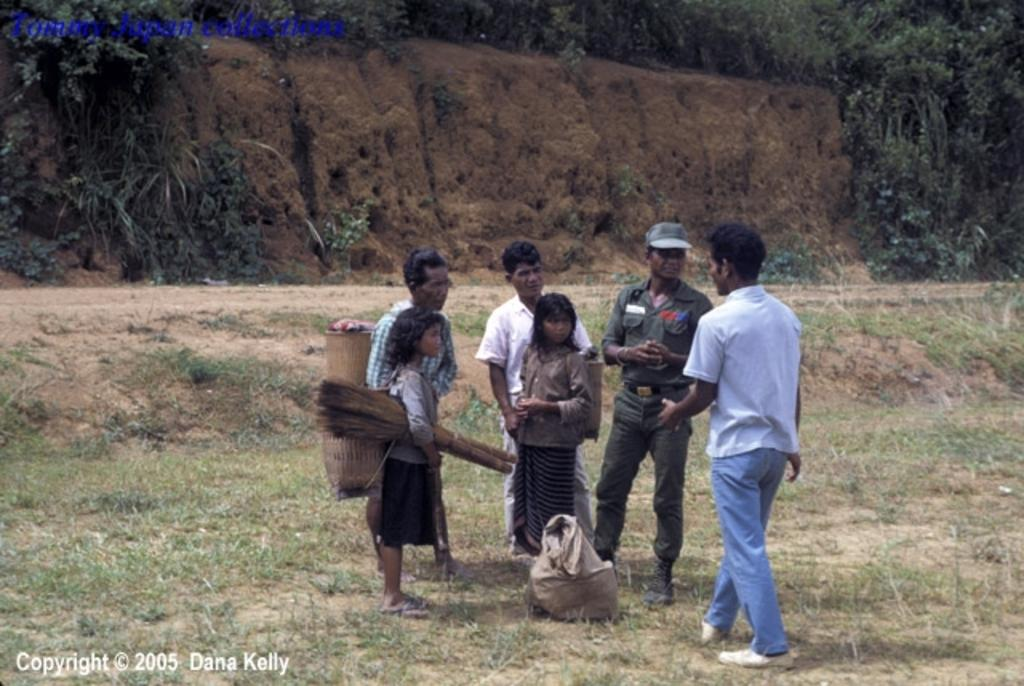What is happening in the image? There are people standing in the image. What are some of the people holding? Some people are holding something. Can you describe any objects in the image? There is a bag visible in the image. What type of natural environment is present in the image? Trees and dry grass are visible in the image. Are there any other notable features in the image? There is a rock in the image. What is the history of the form that the people are holding in the image? There is no form present in the image, and therefore no history can be discussed. 